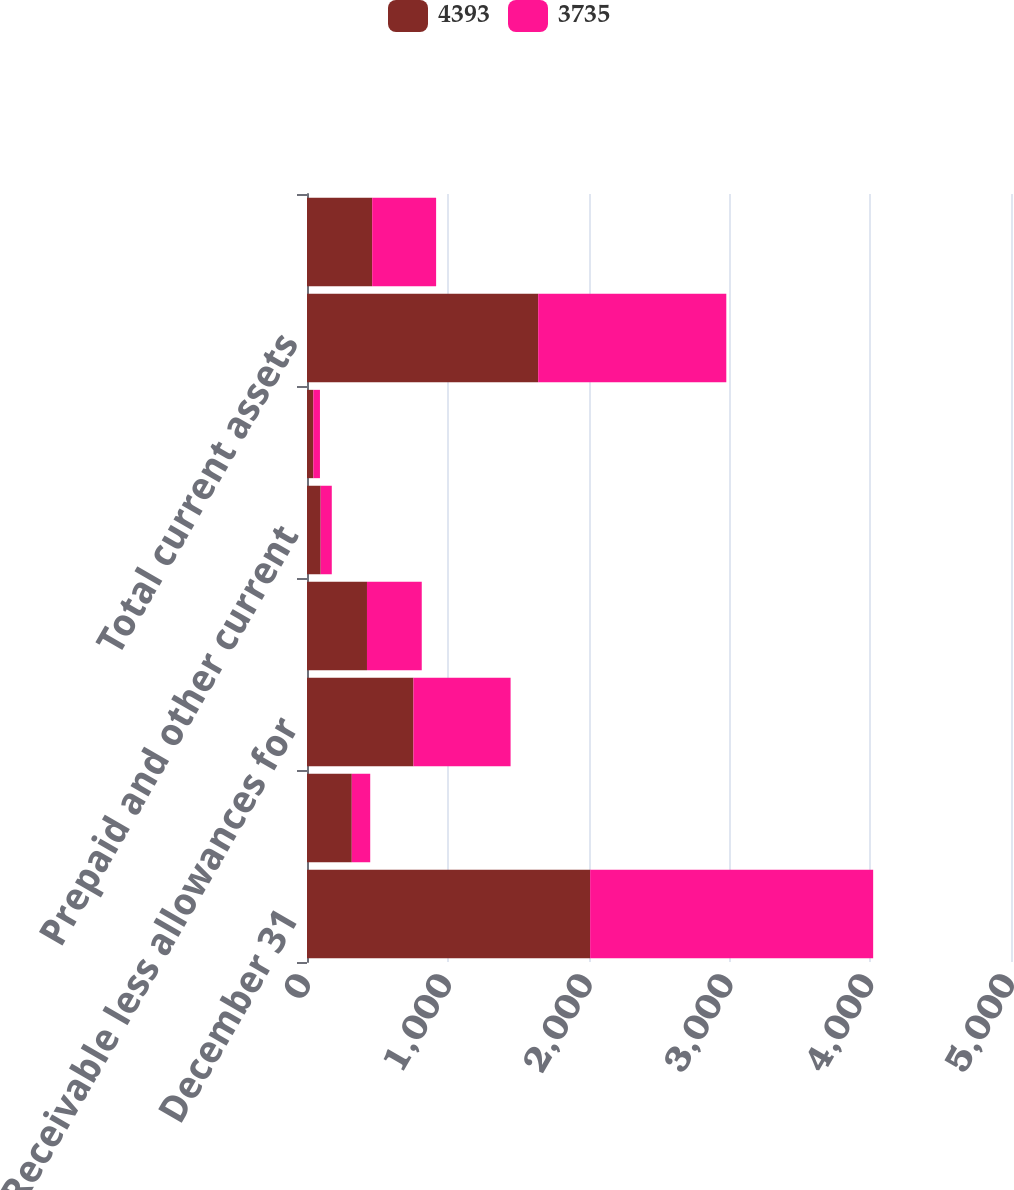<chart> <loc_0><loc_0><loc_500><loc_500><stacked_bar_chart><ecel><fcel>December 31<fcel>Cash and cash equivalents<fcel>Receivable less allowances for<fcel>Inventories net<fcel>Prepaid and other current<fcel>Deferred income tax assets<fcel>Total current assets<fcel>Property plant and equipment<nl><fcel>4393<fcel>2011<fcel>318<fcel>756<fcel>426<fcel>97<fcel>45<fcel>1642<fcel>463<nl><fcel>3735<fcel>2010<fcel>131<fcel>690<fcel>389<fcel>79<fcel>47<fcel>1336<fcel>454<nl></chart> 